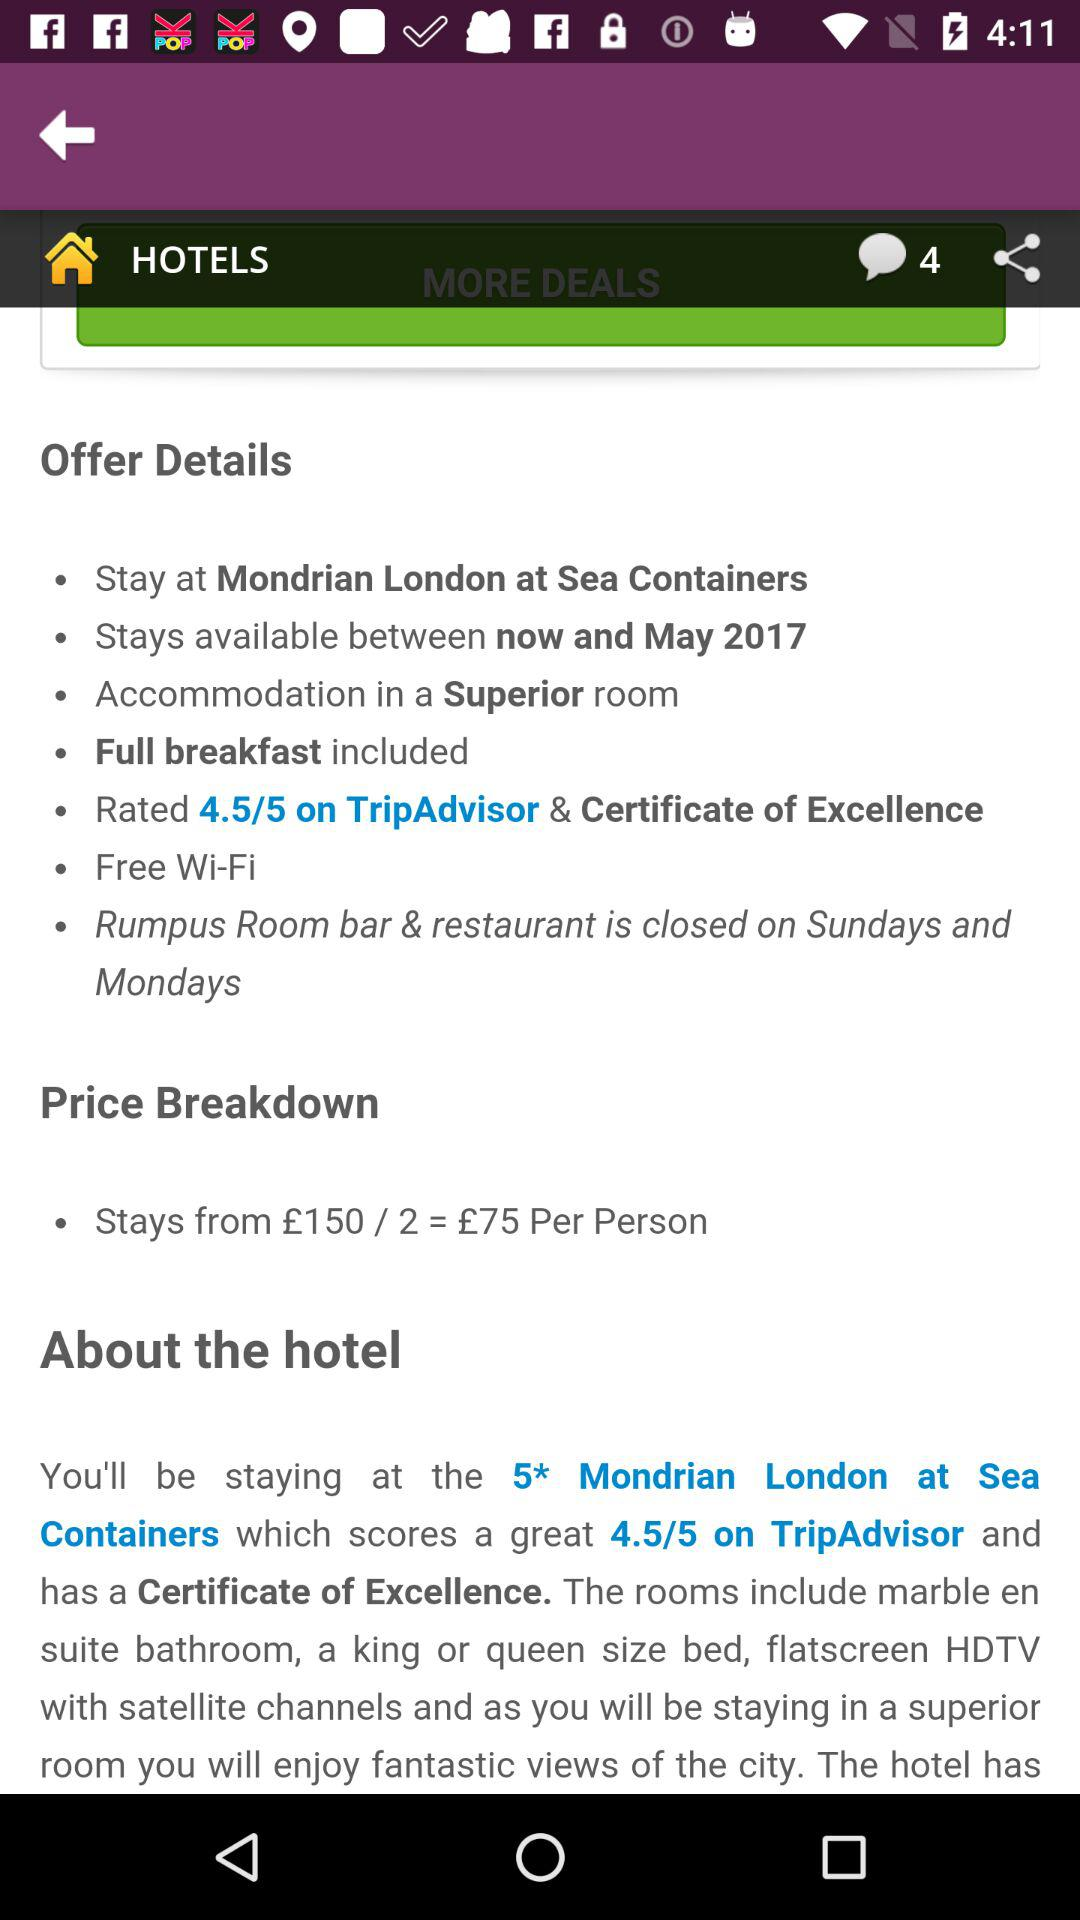What is the price breakdown per person? The price is £75. 